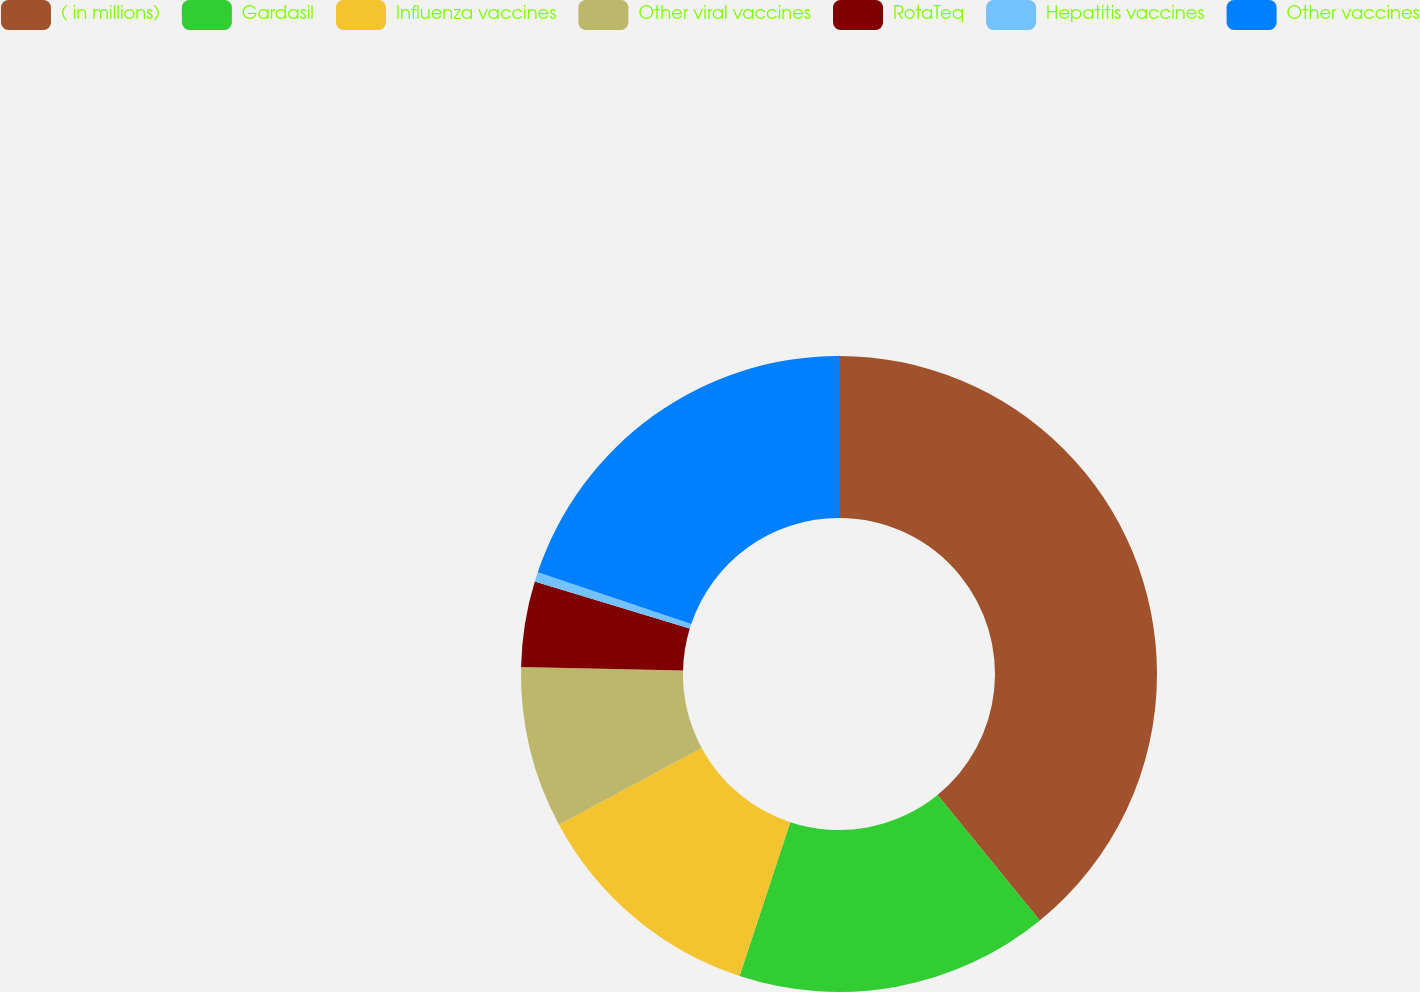Convert chart. <chart><loc_0><loc_0><loc_500><loc_500><pie_chart><fcel>( in millions)<fcel>Gardasil<fcel>Influenza vaccines<fcel>Other viral vaccines<fcel>RotaTeq<fcel>Hepatitis vaccines<fcel>Other vaccines<nl><fcel>39.12%<fcel>15.94%<fcel>12.08%<fcel>8.21%<fcel>4.35%<fcel>0.49%<fcel>19.81%<nl></chart> 